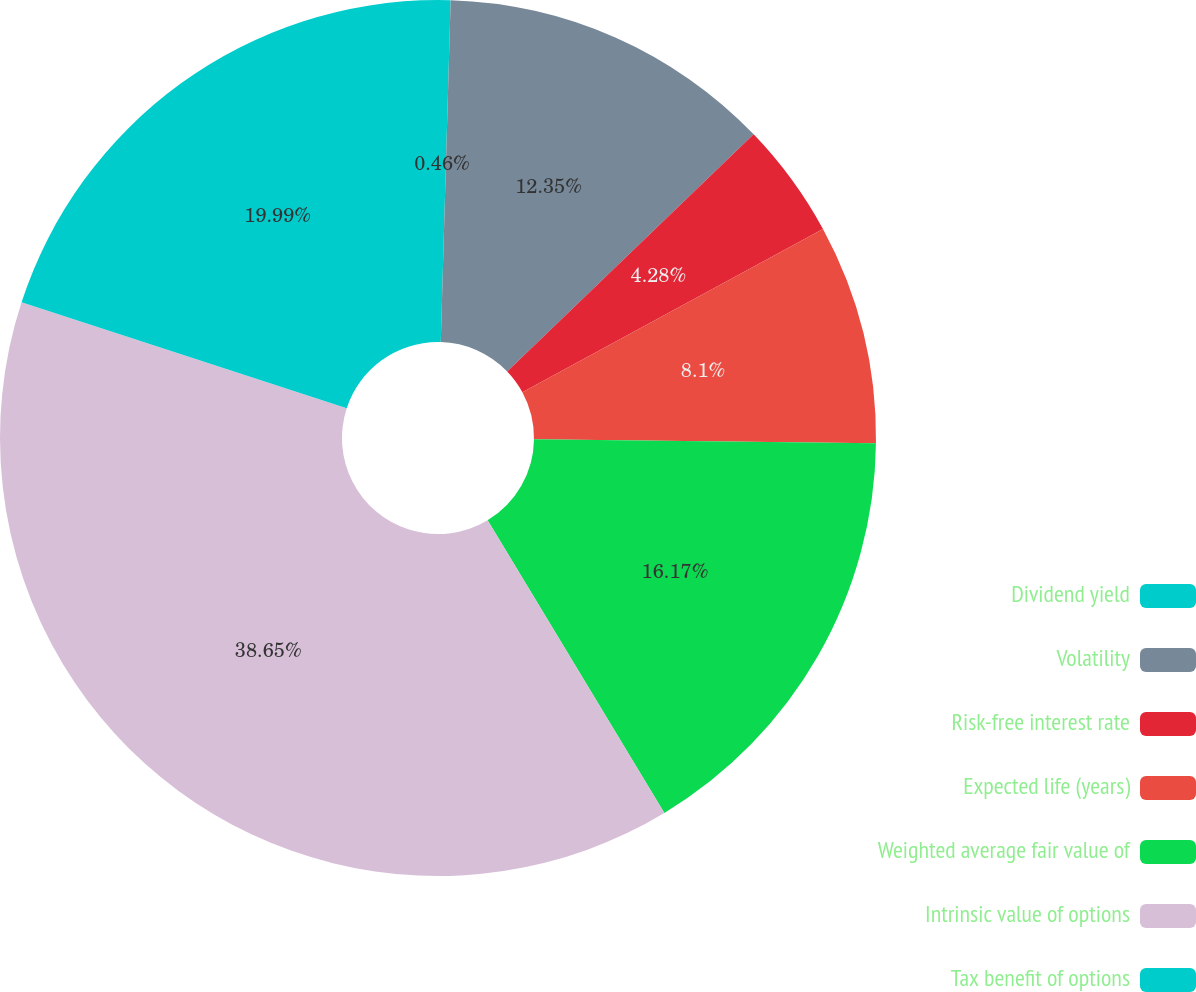Convert chart to OTSL. <chart><loc_0><loc_0><loc_500><loc_500><pie_chart><fcel>Dividend yield<fcel>Volatility<fcel>Risk-free interest rate<fcel>Expected life (years)<fcel>Weighted average fair value of<fcel>Intrinsic value of options<fcel>Tax benefit of options<nl><fcel>0.46%<fcel>12.35%<fcel>4.28%<fcel>8.1%<fcel>16.17%<fcel>38.66%<fcel>19.99%<nl></chart> 